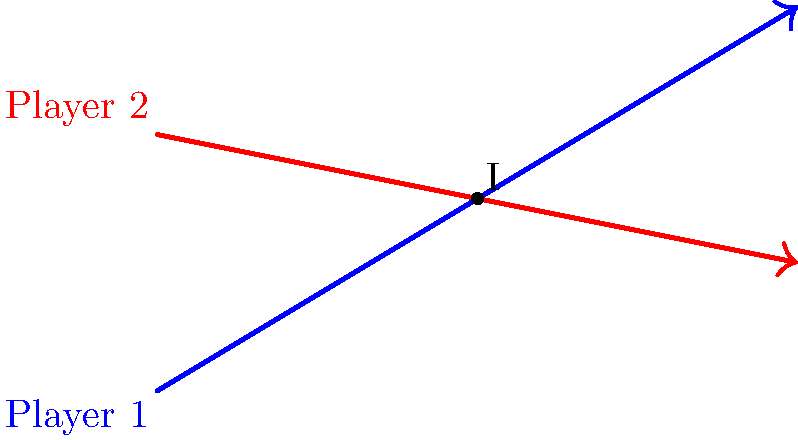During a match between Sheikh Russel Kurmitola Club and their rivals, two players are running on straight paths. Player 1's path is represented by the equation $y = 0.6x$, while Player 2's path is given by $y = -0.2x + 4$. At what point $(x, y)$ will the two players' paths intersect? To find the intersection point of the two player paths, we need to solve the system of equations:

1) Player 1's equation: $y = 0.6x$
2) Player 2's equation: $y = -0.2x + 4$

At the intersection point, both equations will be true. So we can set them equal to each other:

3) $0.6x = -0.2x + 4$

Now, let's solve this equation:

4) $0.6x + 0.2x = 4$
5) $0.8x = 4$
6) $x = 4 / 0.8 = 5$

We've found the $x$-coordinate of the intersection point. To find the $y$-coordinate, we can substitute this $x$ value into either of the original equations. Let's use Player 1's equation:

7) $y = 0.6(5) = 3$

Therefore, the intersection point is $(5, 3)$.
Answer: $(5, 3)$ 